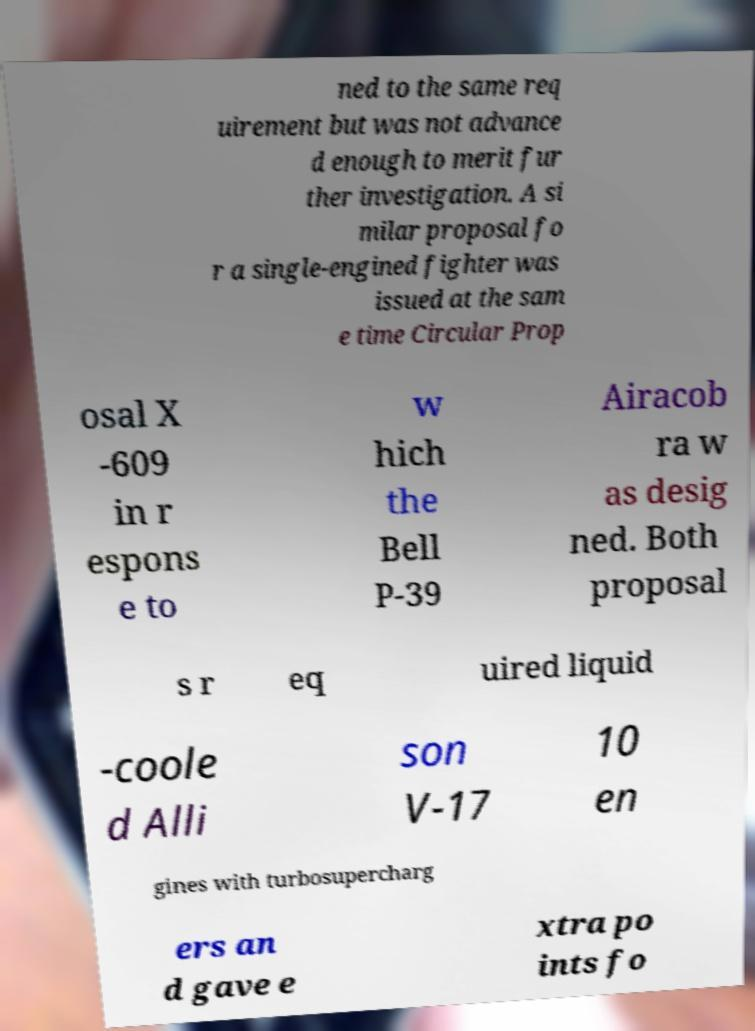I need the written content from this picture converted into text. Can you do that? ned to the same req uirement but was not advance d enough to merit fur ther investigation. A si milar proposal fo r a single-engined fighter was issued at the sam e time Circular Prop osal X -609 in r espons e to w hich the Bell P-39 Airacob ra w as desig ned. Both proposal s r eq uired liquid -coole d Alli son V-17 10 en gines with turbosupercharg ers an d gave e xtra po ints fo 